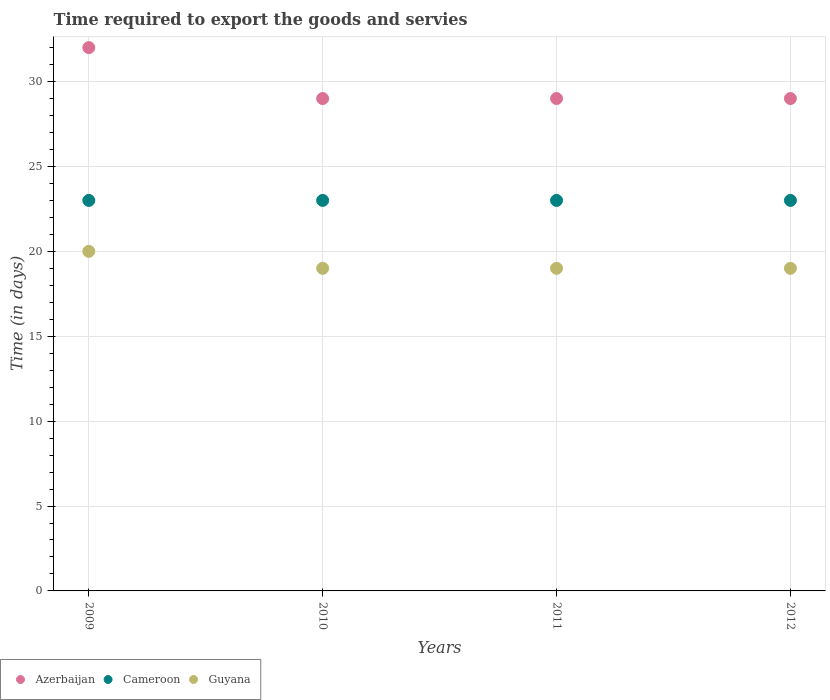How many different coloured dotlines are there?
Offer a very short reply. 3. What is the number of days required to export the goods and services in Guyana in 2009?
Ensure brevity in your answer.  20. Across all years, what is the maximum number of days required to export the goods and services in Cameroon?
Give a very brief answer. 23. Across all years, what is the minimum number of days required to export the goods and services in Guyana?
Give a very brief answer. 19. In which year was the number of days required to export the goods and services in Cameroon maximum?
Your answer should be very brief. 2009. In which year was the number of days required to export the goods and services in Guyana minimum?
Provide a succinct answer. 2010. What is the total number of days required to export the goods and services in Azerbaijan in the graph?
Your response must be concise. 119. What is the difference between the number of days required to export the goods and services in Azerbaijan in 2009 and that in 2011?
Make the answer very short. 3. What is the difference between the number of days required to export the goods and services in Guyana in 2010 and the number of days required to export the goods and services in Azerbaijan in 2012?
Provide a succinct answer. -10. What is the average number of days required to export the goods and services in Cameroon per year?
Offer a terse response. 23. In the year 2010, what is the difference between the number of days required to export the goods and services in Guyana and number of days required to export the goods and services in Cameroon?
Your answer should be very brief. -4. In how many years, is the number of days required to export the goods and services in Guyana greater than 12 days?
Provide a short and direct response. 4. What is the ratio of the number of days required to export the goods and services in Azerbaijan in 2011 to that in 2012?
Provide a short and direct response. 1. What is the difference between the highest and the lowest number of days required to export the goods and services in Cameroon?
Your answer should be compact. 0. Is the sum of the number of days required to export the goods and services in Azerbaijan in 2010 and 2012 greater than the maximum number of days required to export the goods and services in Cameroon across all years?
Your answer should be very brief. Yes. Is the number of days required to export the goods and services in Azerbaijan strictly greater than the number of days required to export the goods and services in Guyana over the years?
Provide a succinct answer. Yes. How many dotlines are there?
Keep it short and to the point. 3. What is the difference between two consecutive major ticks on the Y-axis?
Offer a very short reply. 5. Are the values on the major ticks of Y-axis written in scientific E-notation?
Offer a very short reply. No. What is the title of the graph?
Provide a short and direct response. Time required to export the goods and servies. Does "Sao Tome and Principe" appear as one of the legend labels in the graph?
Keep it short and to the point. No. What is the label or title of the Y-axis?
Ensure brevity in your answer.  Time (in days). What is the Time (in days) in Azerbaijan in 2009?
Provide a short and direct response. 32. What is the Time (in days) in Azerbaijan in 2010?
Your answer should be compact. 29. What is the Time (in days) of Guyana in 2010?
Offer a terse response. 19. What is the Time (in days) of Cameroon in 2011?
Keep it short and to the point. 23. What is the Time (in days) in Azerbaijan in 2012?
Offer a terse response. 29. What is the Time (in days) in Cameroon in 2012?
Your answer should be very brief. 23. What is the Time (in days) in Guyana in 2012?
Offer a very short reply. 19. Across all years, what is the minimum Time (in days) of Azerbaijan?
Offer a very short reply. 29. What is the total Time (in days) in Azerbaijan in the graph?
Offer a very short reply. 119. What is the total Time (in days) of Cameroon in the graph?
Give a very brief answer. 92. What is the difference between the Time (in days) in Azerbaijan in 2009 and that in 2010?
Make the answer very short. 3. What is the difference between the Time (in days) of Cameroon in 2009 and that in 2010?
Offer a very short reply. 0. What is the difference between the Time (in days) of Guyana in 2009 and that in 2010?
Give a very brief answer. 1. What is the difference between the Time (in days) of Azerbaijan in 2009 and that in 2011?
Offer a terse response. 3. What is the difference between the Time (in days) in Cameroon in 2009 and that in 2011?
Provide a short and direct response. 0. What is the difference between the Time (in days) in Guyana in 2009 and that in 2012?
Give a very brief answer. 1. What is the difference between the Time (in days) in Cameroon in 2010 and that in 2011?
Your answer should be very brief. 0. What is the difference between the Time (in days) of Cameroon in 2010 and that in 2012?
Provide a succinct answer. 0. What is the difference between the Time (in days) of Guyana in 2010 and that in 2012?
Keep it short and to the point. 0. What is the difference between the Time (in days) in Azerbaijan in 2011 and that in 2012?
Make the answer very short. 0. What is the difference between the Time (in days) in Cameroon in 2011 and that in 2012?
Your answer should be very brief. 0. What is the difference between the Time (in days) in Azerbaijan in 2009 and the Time (in days) in Cameroon in 2010?
Ensure brevity in your answer.  9. What is the difference between the Time (in days) of Azerbaijan in 2009 and the Time (in days) of Guyana in 2010?
Offer a terse response. 13. What is the difference between the Time (in days) in Cameroon in 2009 and the Time (in days) in Guyana in 2010?
Make the answer very short. 4. What is the difference between the Time (in days) in Azerbaijan in 2009 and the Time (in days) in Cameroon in 2012?
Give a very brief answer. 9. What is the difference between the Time (in days) of Azerbaijan in 2009 and the Time (in days) of Guyana in 2012?
Make the answer very short. 13. What is the difference between the Time (in days) of Azerbaijan in 2010 and the Time (in days) of Cameroon in 2011?
Your answer should be compact. 6. What is the difference between the Time (in days) in Azerbaijan in 2010 and the Time (in days) in Guyana in 2011?
Give a very brief answer. 10. What is the difference between the Time (in days) in Azerbaijan in 2010 and the Time (in days) in Cameroon in 2012?
Your answer should be very brief. 6. What is the difference between the Time (in days) of Azerbaijan in 2010 and the Time (in days) of Guyana in 2012?
Provide a short and direct response. 10. What is the average Time (in days) of Azerbaijan per year?
Provide a short and direct response. 29.75. What is the average Time (in days) in Guyana per year?
Your answer should be compact. 19.25. In the year 2009, what is the difference between the Time (in days) in Cameroon and Time (in days) in Guyana?
Ensure brevity in your answer.  3. In the year 2010, what is the difference between the Time (in days) of Azerbaijan and Time (in days) of Cameroon?
Offer a terse response. 6. In the year 2011, what is the difference between the Time (in days) of Azerbaijan and Time (in days) of Guyana?
Provide a succinct answer. 10. In the year 2012, what is the difference between the Time (in days) of Azerbaijan and Time (in days) of Cameroon?
Your response must be concise. 6. In the year 2012, what is the difference between the Time (in days) in Azerbaijan and Time (in days) in Guyana?
Give a very brief answer. 10. In the year 2012, what is the difference between the Time (in days) in Cameroon and Time (in days) in Guyana?
Offer a terse response. 4. What is the ratio of the Time (in days) in Azerbaijan in 2009 to that in 2010?
Your response must be concise. 1.1. What is the ratio of the Time (in days) in Guyana in 2009 to that in 2010?
Keep it short and to the point. 1.05. What is the ratio of the Time (in days) in Azerbaijan in 2009 to that in 2011?
Provide a succinct answer. 1.1. What is the ratio of the Time (in days) of Cameroon in 2009 to that in 2011?
Your answer should be compact. 1. What is the ratio of the Time (in days) in Guyana in 2009 to that in 2011?
Provide a short and direct response. 1.05. What is the ratio of the Time (in days) of Azerbaijan in 2009 to that in 2012?
Make the answer very short. 1.1. What is the ratio of the Time (in days) in Cameroon in 2009 to that in 2012?
Ensure brevity in your answer.  1. What is the ratio of the Time (in days) in Guyana in 2009 to that in 2012?
Your answer should be compact. 1.05. What is the ratio of the Time (in days) of Azerbaijan in 2010 to that in 2011?
Offer a very short reply. 1. What is the ratio of the Time (in days) of Cameroon in 2010 to that in 2011?
Provide a succinct answer. 1. What is the ratio of the Time (in days) of Guyana in 2010 to that in 2012?
Make the answer very short. 1. What is the ratio of the Time (in days) in Azerbaijan in 2011 to that in 2012?
Ensure brevity in your answer.  1. What is the ratio of the Time (in days) in Guyana in 2011 to that in 2012?
Your response must be concise. 1. What is the difference between the highest and the second highest Time (in days) in Guyana?
Your answer should be very brief. 1. What is the difference between the highest and the lowest Time (in days) of Azerbaijan?
Provide a succinct answer. 3. What is the difference between the highest and the lowest Time (in days) of Guyana?
Ensure brevity in your answer.  1. 